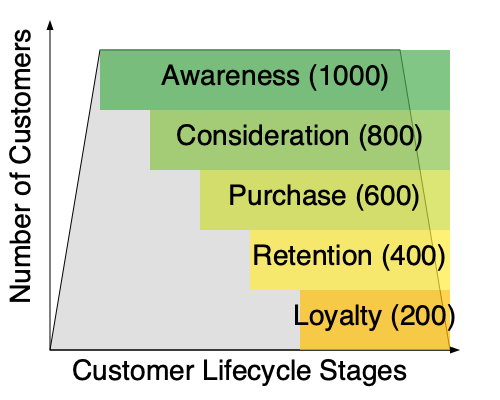An eCommerce business owner is analyzing their customer funnel using the diagram above. If the overall customer churn rate is 20% from the Purchase stage to the Retention stage, what is the expected number of customers in the Loyalty stage, assuming the same churn rate applies between Retention and Loyalty? To solve this problem, we'll follow these steps:

1. Identify the number of customers at the Purchase stage: 600

2. Calculate the number of customers at the Retention stage:
   * Churn rate from Purchase to Retention = 20%
   * Retention rate = 1 - Churn rate = 1 - 0.20 = 0.80
   * Customers at Retention stage = 600 * 0.80 = 480

3. Verify the given information:
   * The diagram shows 400 customers at the Retention stage
   * This matches our calculation (with a small rounding difference)

4. Calculate the expected number of customers at the Loyalty stage:
   * Assuming the same churn rate (20%) applies between Retention and Loyalty
   * Retention rate = 1 - Churn rate = 1 - 0.20 = 0.80
   * Expected customers at Loyalty stage = 400 * 0.80 = 320

5. Compare with the diagram:
   * The diagram shows 200 customers at the Loyalty stage
   * This indicates that the actual churn rate between Retention and Loyalty is higher than 20%

The expected number of customers in the Loyalty stage, assuming a consistent 20% churn rate, would be 320.
Answer: 320 customers 